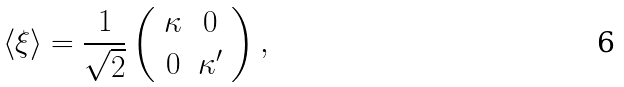<formula> <loc_0><loc_0><loc_500><loc_500>\langle \xi \rangle = \frac { 1 } { \sqrt { 2 } } \left ( \begin{array} { c c } \kappa & 0 \\ 0 & \kappa ^ { \prime } \end{array} \right ) ,</formula> 